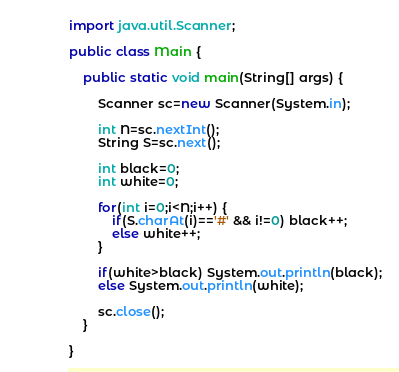<code> <loc_0><loc_0><loc_500><loc_500><_Java_>import java.util.Scanner;

public class Main {

	public static void main(String[] args) {

		Scanner sc=new Scanner(System.in);

		int N=sc.nextInt();
		String S=sc.next();

		int black=0;
		int white=0;

		for(int i=0;i<N;i++) {
			if(S.charAt(i)=='#' && i!=0) black++;
			else white++;
		}

		if(white>black) System.out.println(black);
		else System.out.println(white);

		sc.close();
	}

}
</code> 